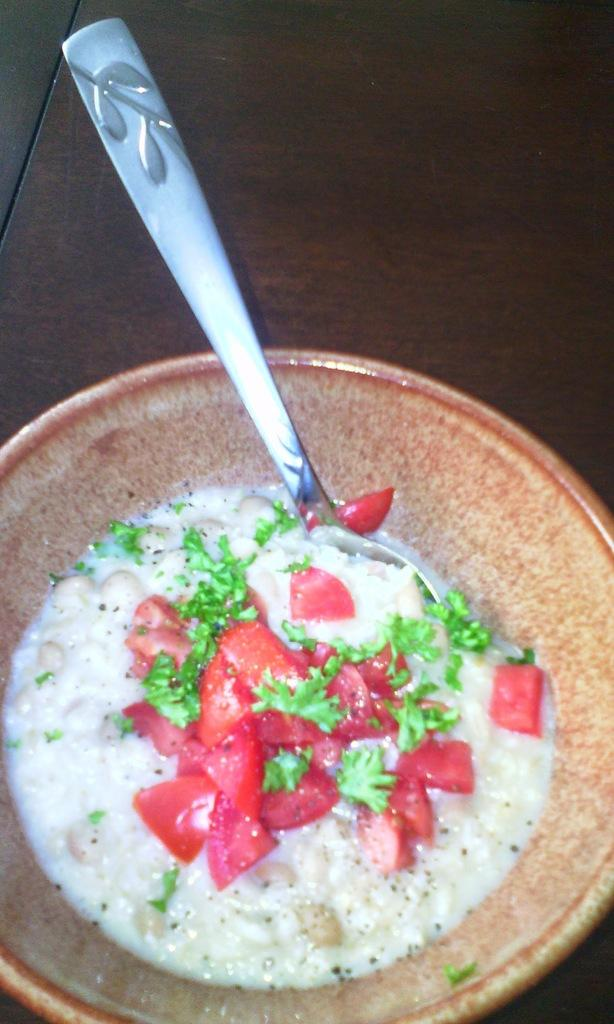What is the main object in the image? There is a bowl in the image. What is the bowl placed on? The bowl is on a wooden surface. What is inside the bowl? There are food items in the bowl. What utensil is present in the bowl? There is a spoon in the bowl. What ingredients can be identified in the food? The food contains tomatoes and parsley. Is there a slope visible in the image? No, there is no slope visible in the image. The image features a bowl with food items and a spoon on a wooden surface, with no indication of a slope. 